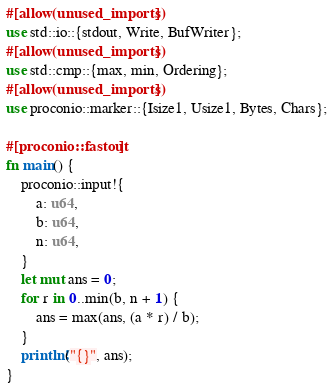<code> <loc_0><loc_0><loc_500><loc_500><_Rust_>#[allow(unused_imports)]
use std::io::{stdout, Write, BufWriter};
#[allow(unused_imports)]
use std::cmp::{max, min, Ordering};
#[allow(unused_imports)]
use proconio::marker::{Isize1, Usize1, Bytes, Chars};

#[proconio::fastout]
fn main() {
    proconio::input!{
        a: u64,
        b: u64,
        n: u64,
    }
    let mut ans = 0;
    for r in 0..min(b, n + 1) {
        ans = max(ans, (a * r) / b);
    }
    println!("{}", ans);
}
</code> 